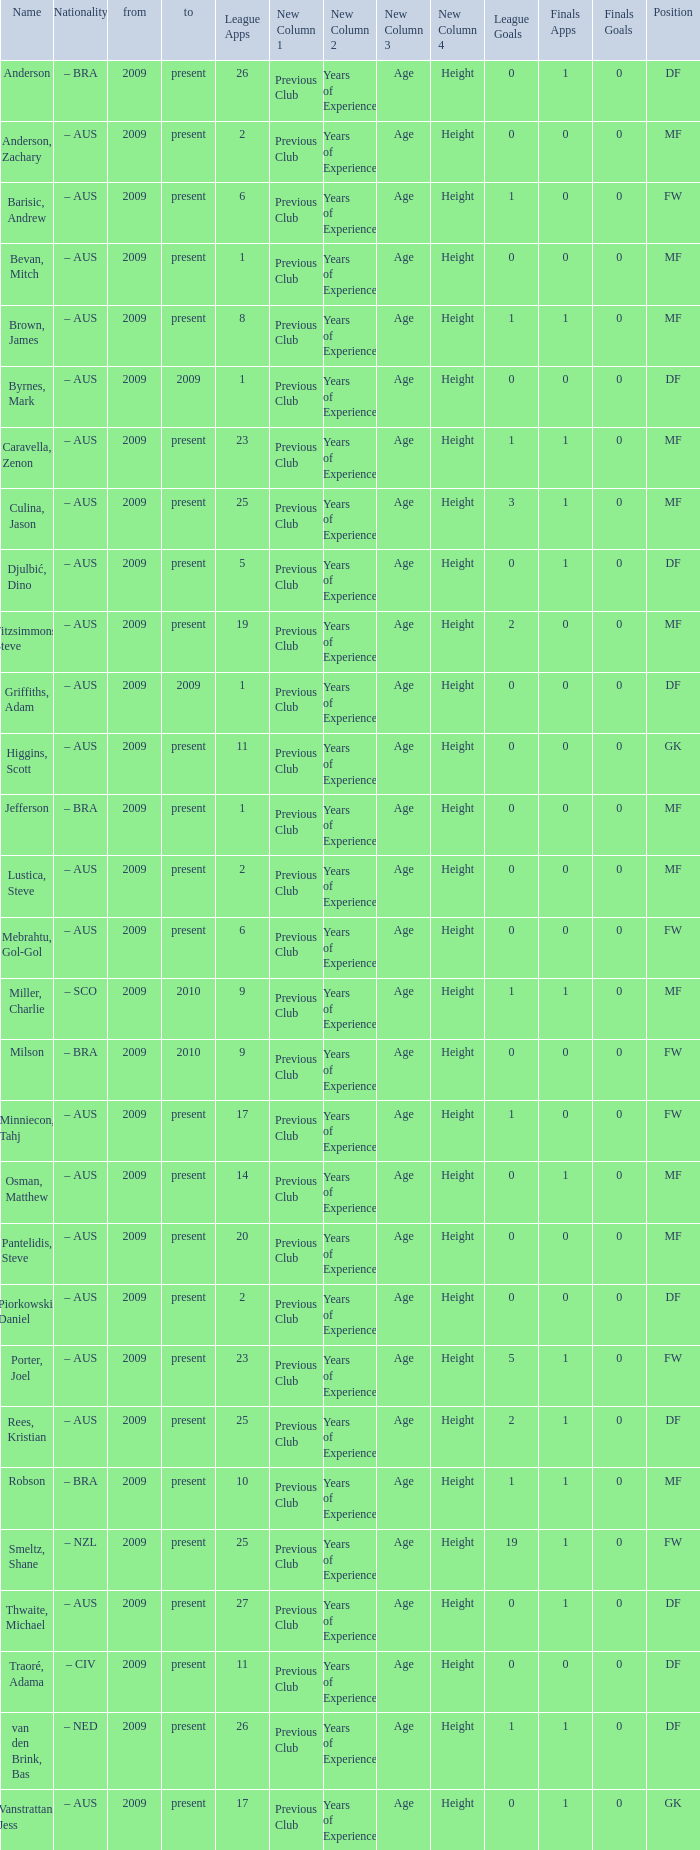Name the position for van den brink, bas DF. 